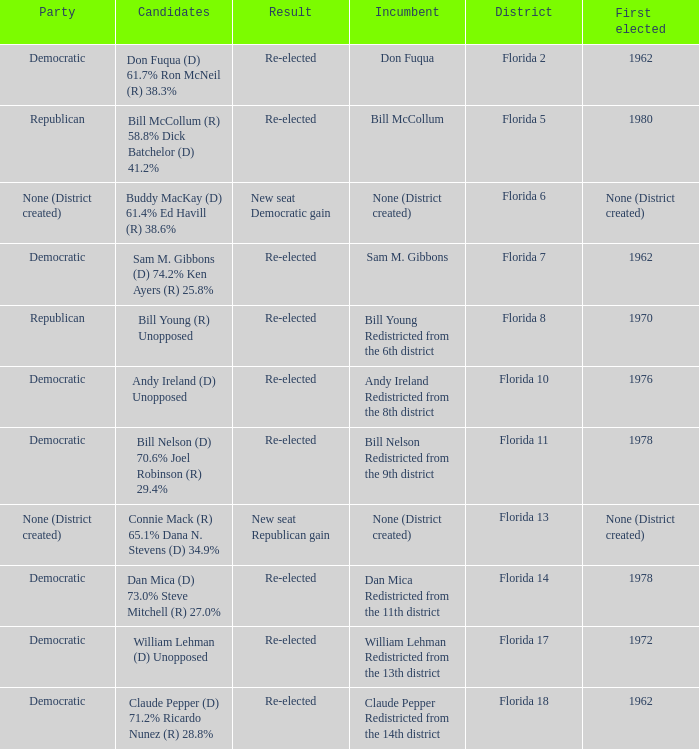What's the result with district being florida 7 Re-elected. 